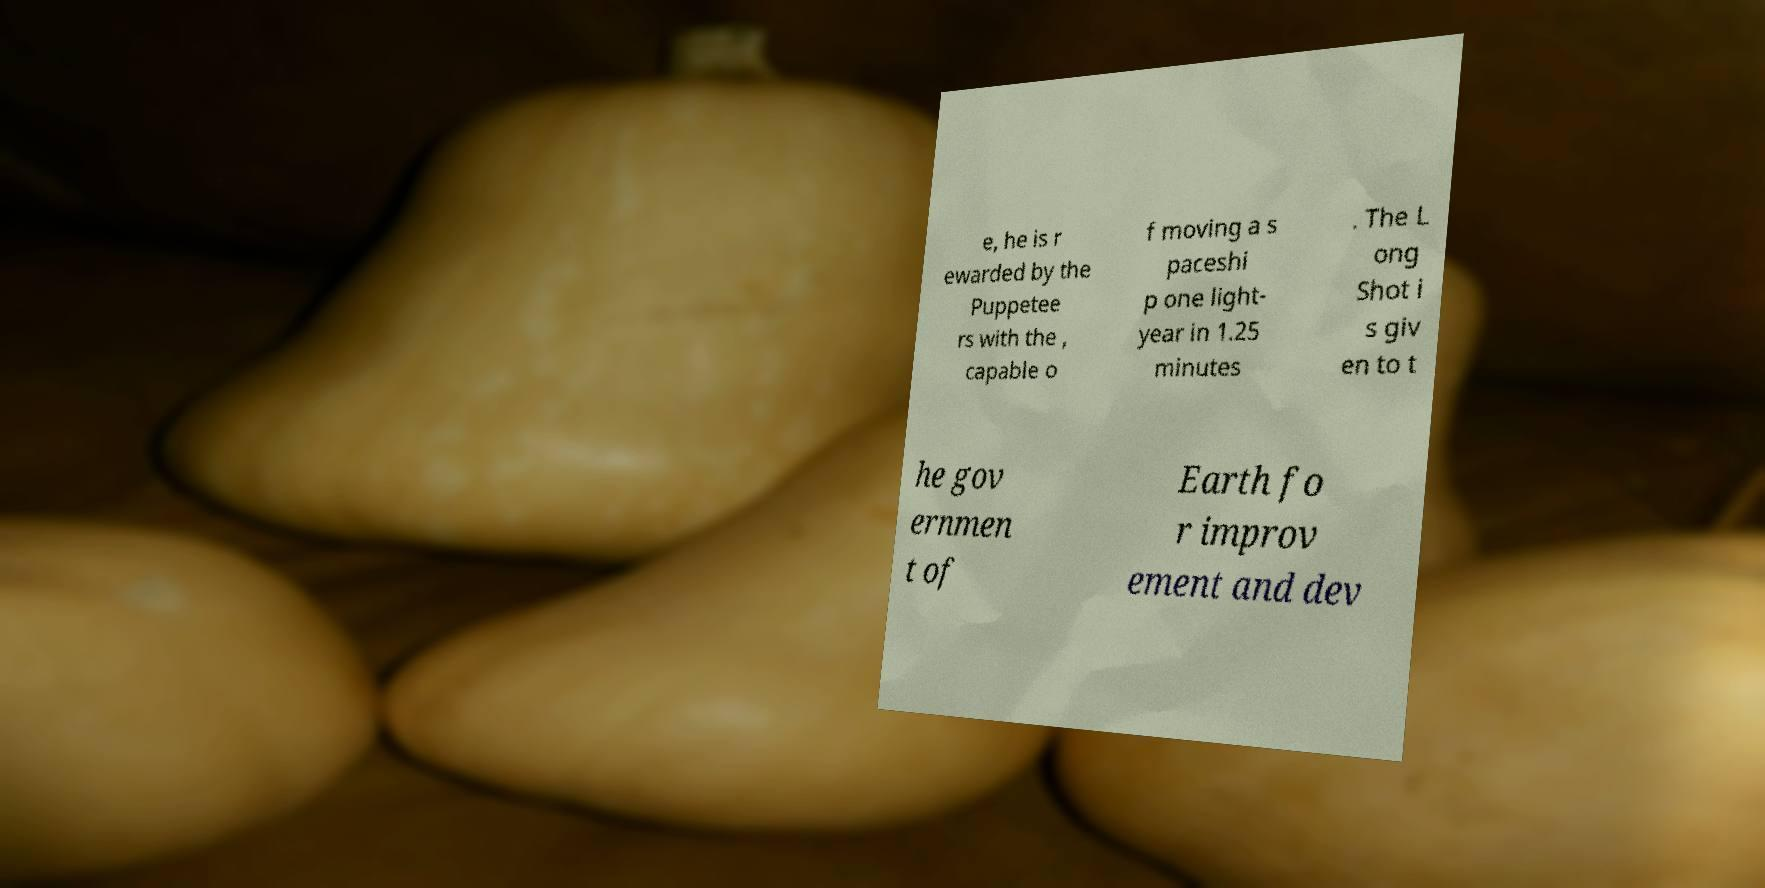Please read and relay the text visible in this image. What does it say? e, he is r ewarded by the Puppetee rs with the , capable o f moving a s paceshi p one light- year in 1.25 minutes . The L ong Shot i s giv en to t he gov ernmen t of Earth fo r improv ement and dev 